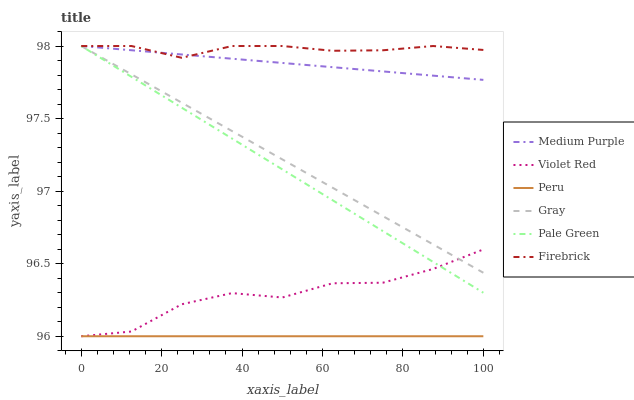Does Peru have the minimum area under the curve?
Answer yes or no. Yes. Does Firebrick have the maximum area under the curve?
Answer yes or no. Yes. Does Violet Red have the minimum area under the curve?
Answer yes or no. No. Does Violet Red have the maximum area under the curve?
Answer yes or no. No. Is Peru the smoothest?
Answer yes or no. Yes. Is Violet Red the roughest?
Answer yes or no. Yes. Is Firebrick the smoothest?
Answer yes or no. No. Is Firebrick the roughest?
Answer yes or no. No. Does Firebrick have the lowest value?
Answer yes or no. No. Does Pale Green have the highest value?
Answer yes or no. Yes. Does Violet Red have the highest value?
Answer yes or no. No. Is Violet Red less than Firebrick?
Answer yes or no. Yes. Is Firebrick greater than Violet Red?
Answer yes or no. Yes. Does Medium Purple intersect Pale Green?
Answer yes or no. Yes. Is Medium Purple less than Pale Green?
Answer yes or no. No. Is Medium Purple greater than Pale Green?
Answer yes or no. No. Does Violet Red intersect Firebrick?
Answer yes or no. No. 